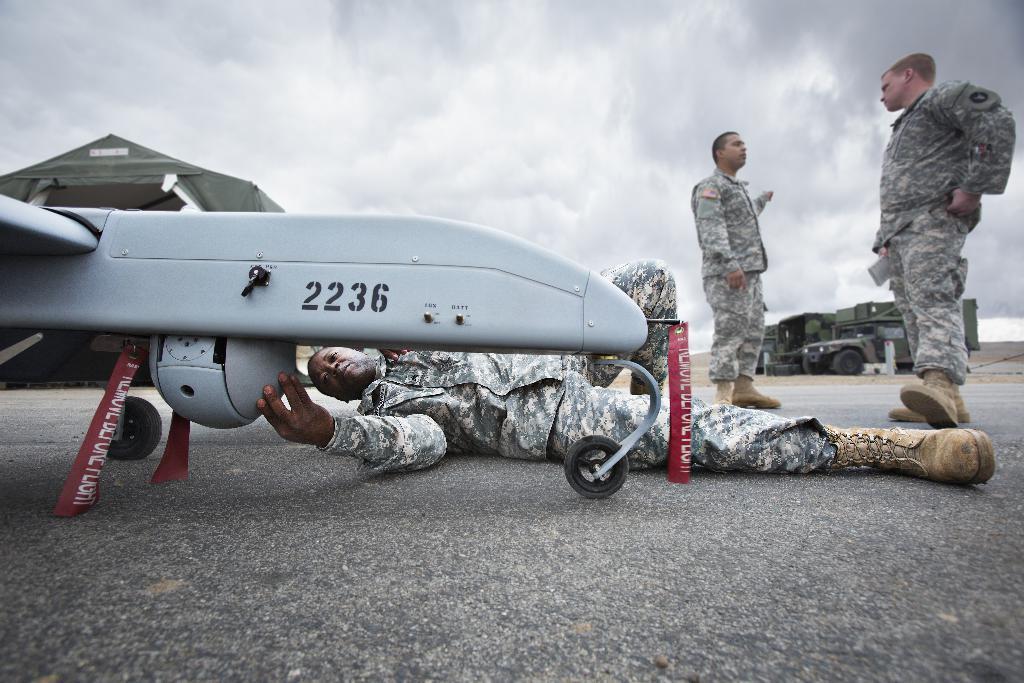In one or two sentences, can you explain what this image depicts? In this image on the right side there are two persons who are standing, on the left side there is one airplane. And in the center there is one person who is lying and he is doing something, at the bottom there is road and in the background there are some vehicles and at the top of the image there is sky. 